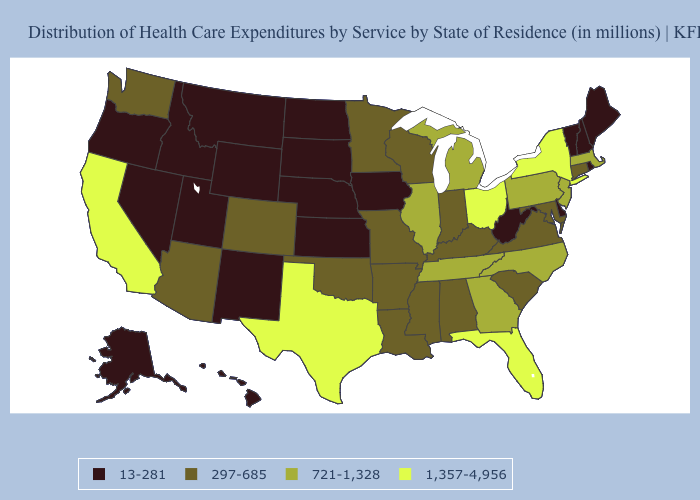Name the states that have a value in the range 1,357-4,956?
Quick response, please. California, Florida, New York, Ohio, Texas. Does Utah have the lowest value in the West?
Answer briefly. Yes. Name the states that have a value in the range 13-281?
Short answer required. Alaska, Delaware, Hawaii, Idaho, Iowa, Kansas, Maine, Montana, Nebraska, Nevada, New Hampshire, New Mexico, North Dakota, Oregon, Rhode Island, South Dakota, Utah, Vermont, West Virginia, Wyoming. Name the states that have a value in the range 13-281?
Concise answer only. Alaska, Delaware, Hawaii, Idaho, Iowa, Kansas, Maine, Montana, Nebraska, Nevada, New Hampshire, New Mexico, North Dakota, Oregon, Rhode Island, South Dakota, Utah, Vermont, West Virginia, Wyoming. Which states have the highest value in the USA?
Quick response, please. California, Florida, New York, Ohio, Texas. Does New Mexico have the lowest value in the USA?
Short answer required. Yes. What is the value of South Carolina?
Quick response, please. 297-685. Name the states that have a value in the range 297-685?
Be succinct. Alabama, Arizona, Arkansas, Colorado, Connecticut, Indiana, Kentucky, Louisiana, Maryland, Minnesota, Mississippi, Missouri, Oklahoma, South Carolina, Virginia, Washington, Wisconsin. What is the value of Nebraska?
Concise answer only. 13-281. What is the lowest value in the USA?
Concise answer only. 13-281. Does Utah have the lowest value in the West?
Short answer required. Yes. Name the states that have a value in the range 1,357-4,956?
Keep it brief. California, Florida, New York, Ohio, Texas. What is the value of Washington?
Short answer required. 297-685. Name the states that have a value in the range 13-281?
Keep it brief. Alaska, Delaware, Hawaii, Idaho, Iowa, Kansas, Maine, Montana, Nebraska, Nevada, New Hampshire, New Mexico, North Dakota, Oregon, Rhode Island, South Dakota, Utah, Vermont, West Virginia, Wyoming. How many symbols are there in the legend?
Short answer required. 4. 